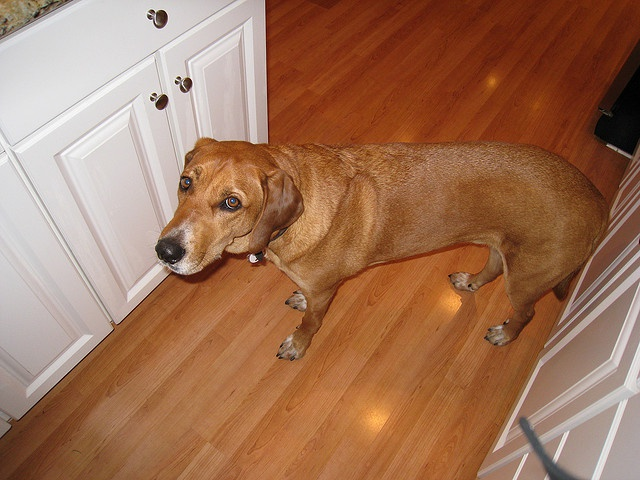Describe the objects in this image and their specific colors. I can see a dog in olive, brown, gray, and maroon tones in this image. 